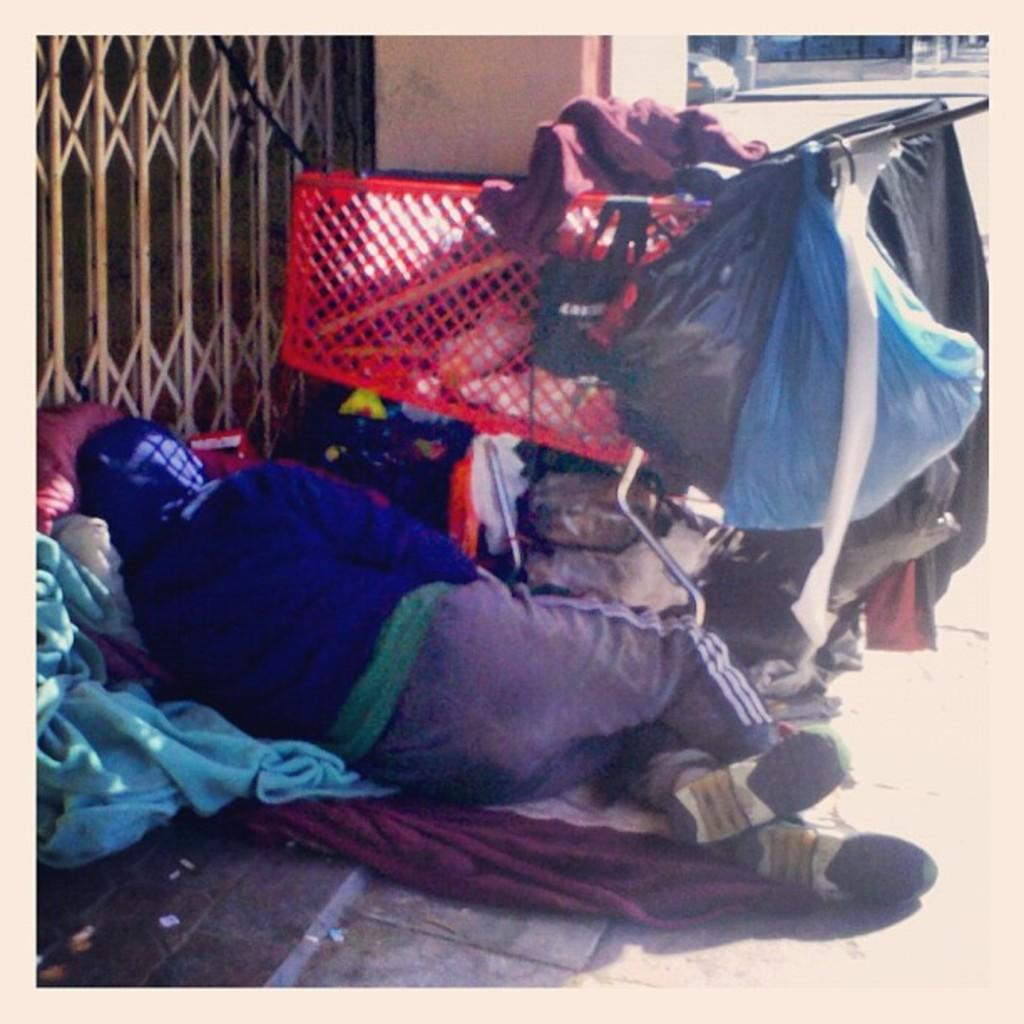What is the person in the image doing? The person is lying on the floor in the image. What else can be seen around the person? There are clothes around the person. What else is on the floor in the image? There are objects on the floor. What type of security feature is present in the image? There is a door grill attached to the wall in the image. How many beetles can be seen crawling on the person in the image? There are no beetles present in the image; the person is lying on the floor with clothes and objects around them. 